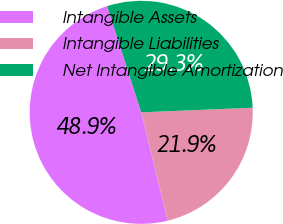Convert chart to OTSL. <chart><loc_0><loc_0><loc_500><loc_500><pie_chart><fcel>Intangible Assets<fcel>Intangible Liabilities<fcel>Net Intangible Amortization<nl><fcel>48.88%<fcel>21.85%<fcel>29.27%<nl></chart> 